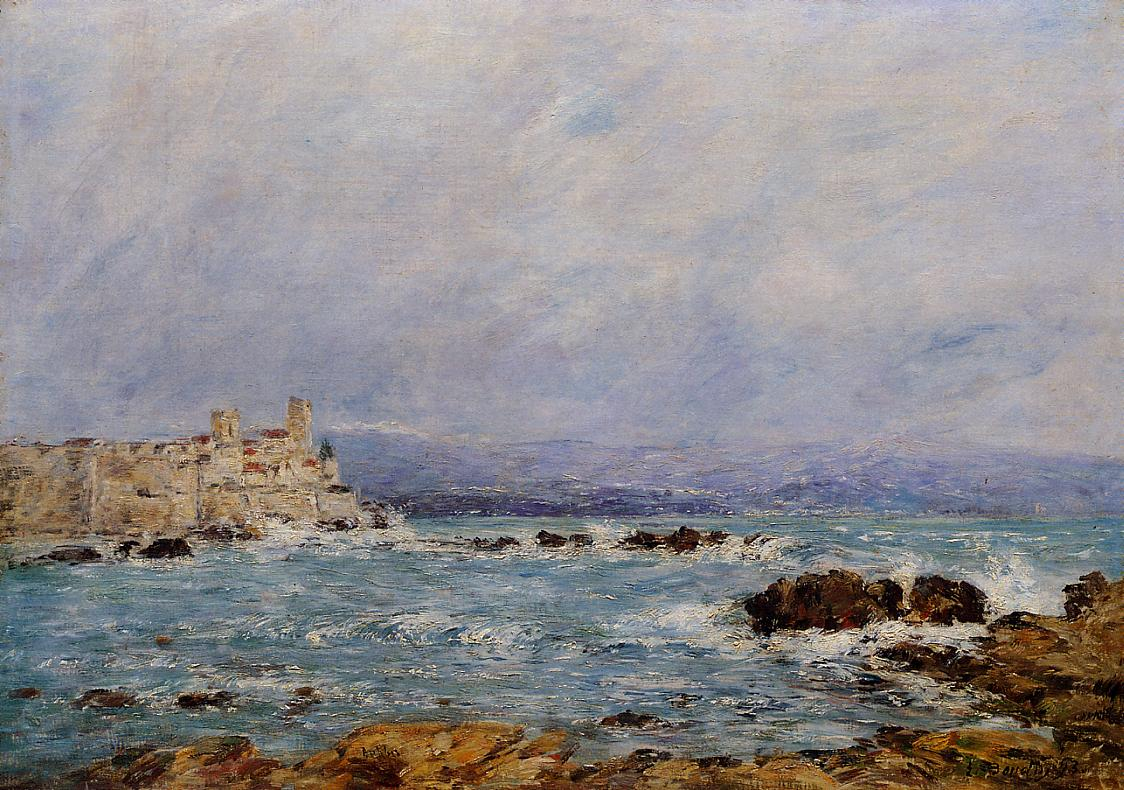Create a fictional story about a hidden treasure found in this setting. Once upon a time, in a quaint coastal village near the towering cliff castle, legend spoke of an ancient treasure buried deep within the rocky shoreline. Francoise, a young fisherman, often heard tales of gold and jewels from his grandfather. One stormy night, Francoise discovered a weathered map sealed in a bottle washed ashore. Intrigued, he set off at dawn, following the map's cryptic clues along the moss-covered rocks. He stumbled upon a hidden cave, its entrance concealed by the crashing waves. Inside, faint glimmers revealed a chest filled with gold coins, gemstones, and a letter from a long-lost pirate captain, thanking the finder for ending his quest. Francoise's discovery brought prosperity to his humble village, and the once-quiet shore became a place of adventure and whispers of more undiscovered treasures waiting to be found. What kind of adventures might Francoise undertake in his quest for the treasure? Francoise's quest for the treasure led him through a series of thrilling adventures. He navigated treacherous waters to a hidden island where he decoded ancient runes etched on cave walls. He evaded cunning traps set to protect the treasure, solved complex puzzles left by the pirate captain, and deciphered clues using his knowledge of the stars and tides. Alongside mythical sea creatures and bustling maritime markets, Francoise faced storms, forging alliances with fellow seekers and overcoming skepticism from his village. His journey was one of courage, intellect, and heart, culminating in the legendary discovery that turned myths into reality. Can you describe the village near the castle? Nestled along the rugged coastline, the village near the castle was a picturesque cluster of stone cottages with thatched roofs, their chimneys gently smoking with the aroma of home-cooked meals. Winding cobblestone streets led to a bustling market square where fishermen sold their daily catch, and artisans displayed their crafts. The scent of saltwater mingled with the fresh bread from the village bakery. Children played along the shore, their laughter mingling with the sound of the waves. The castle, ever-watchful, provided a majestic backdrop, a reminder of the village's rich history and resilient spirit. Lanterns cast a warm glow as night fell, creating a sense of community and timeless charm. 